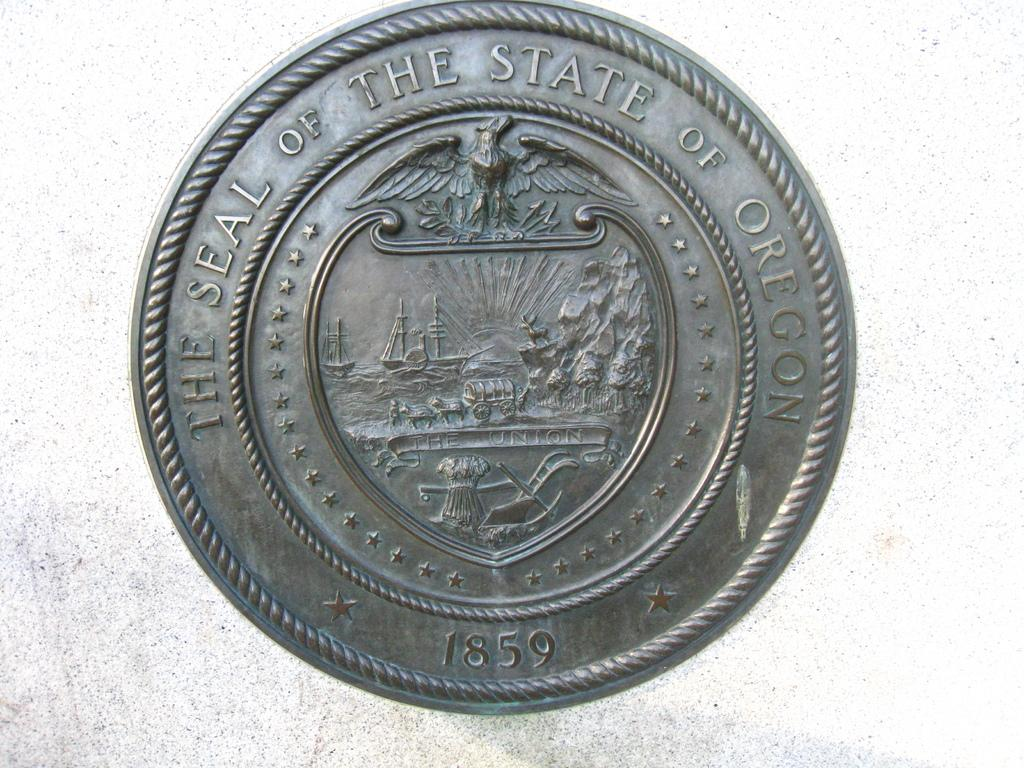<image>
Describe the image concisely. a brass plaque for the Seal of the State of Oregon 1859 